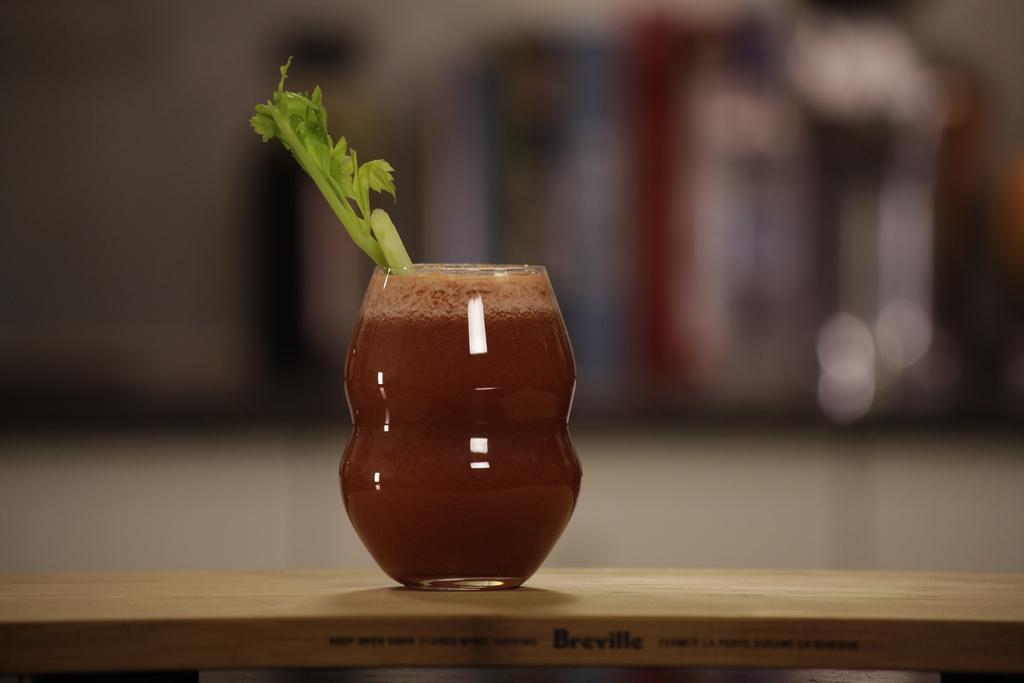In one or two sentences, can you explain what this image depicts? In this picture there is a glass of juice in the center of the image and there is a stem in the glass. 